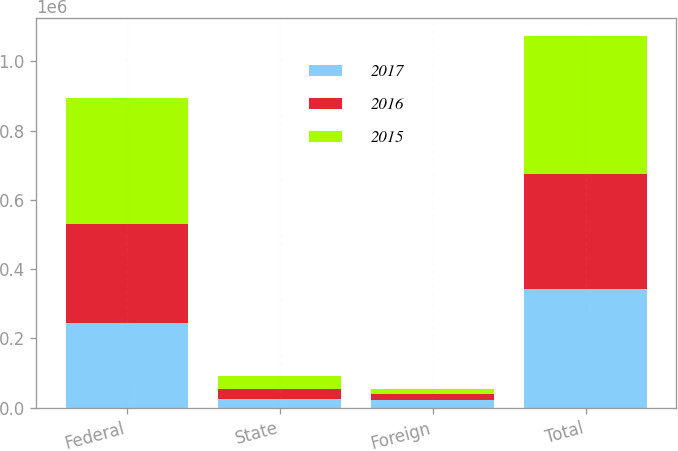Convert chart. <chart><loc_0><loc_0><loc_500><loc_500><stacked_bar_chart><ecel><fcel>Federal<fcel>State<fcel>Foreign<fcel>Total<nl><fcel>2017<fcel>245189<fcel>24898<fcel>21138<fcel>342080<nl><fcel>2016<fcel>284489<fcel>28406<fcel>19017<fcel>331747<nl><fcel>2015<fcel>363803<fcel>37811<fcel>12826<fcel>397956<nl></chart> 